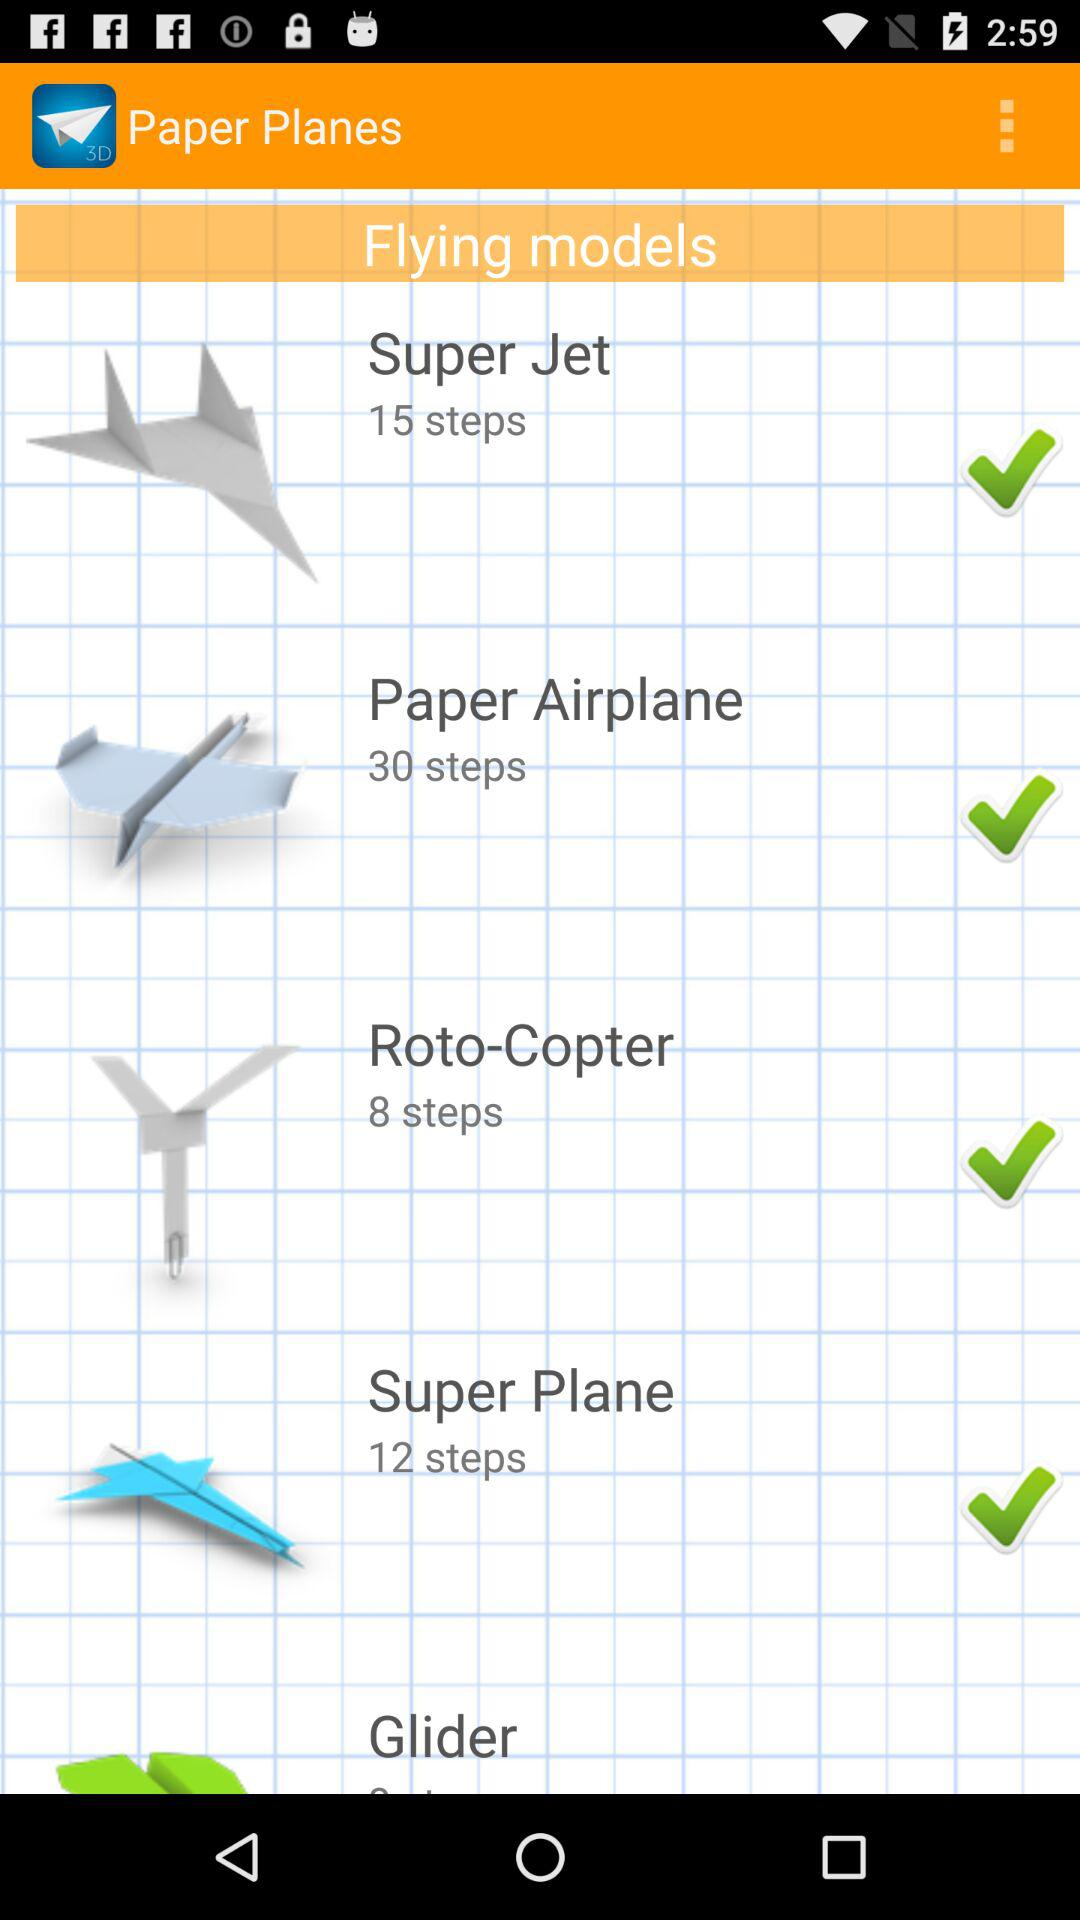What's the number of steps to make "Super Jet"? The number of steps to make "Super Jet" is 15. 